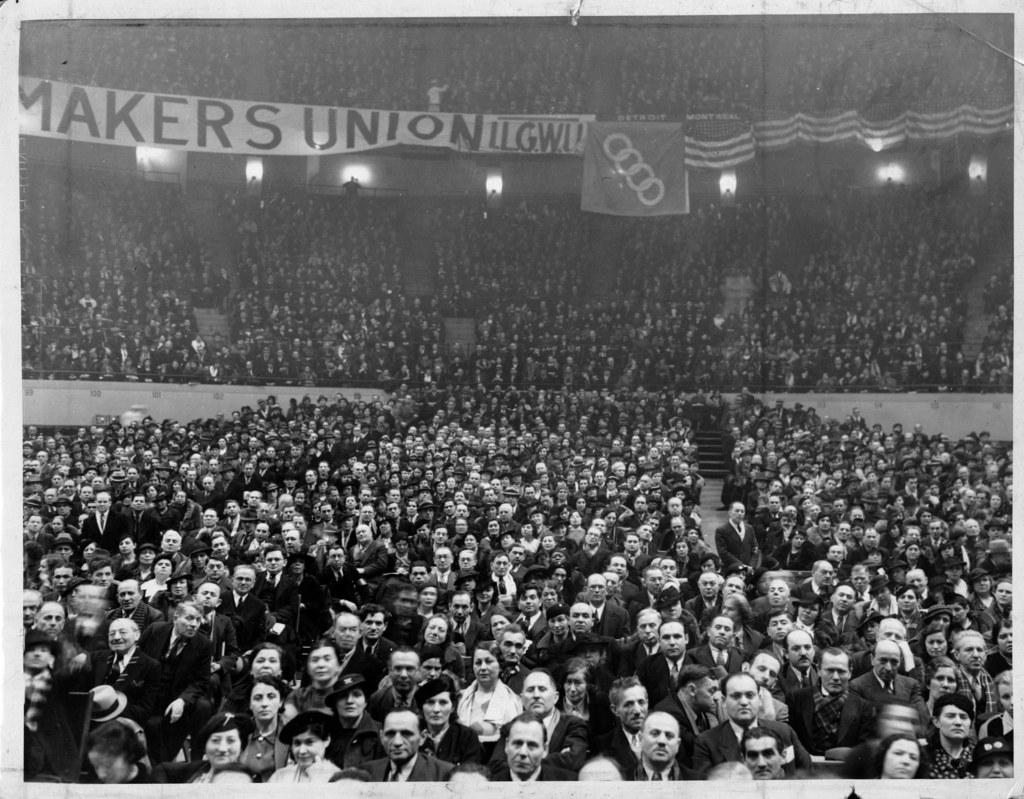How many people are in the image? There are people in the image, but the exact number is not specified. What are the people doing in the image? The people are sitting on chairs and watching something. Can you describe the seating arrangement in the image? The people are sitting on chairs, but the specific arrangement is not mentioned. What type of pan is being used by the people in the image? There is no pan present in the image; the people are sitting on chairs and watching something. What kind of music can be heard in the background of the image? There is no mention of music in the image; the people are focused on watching something. 